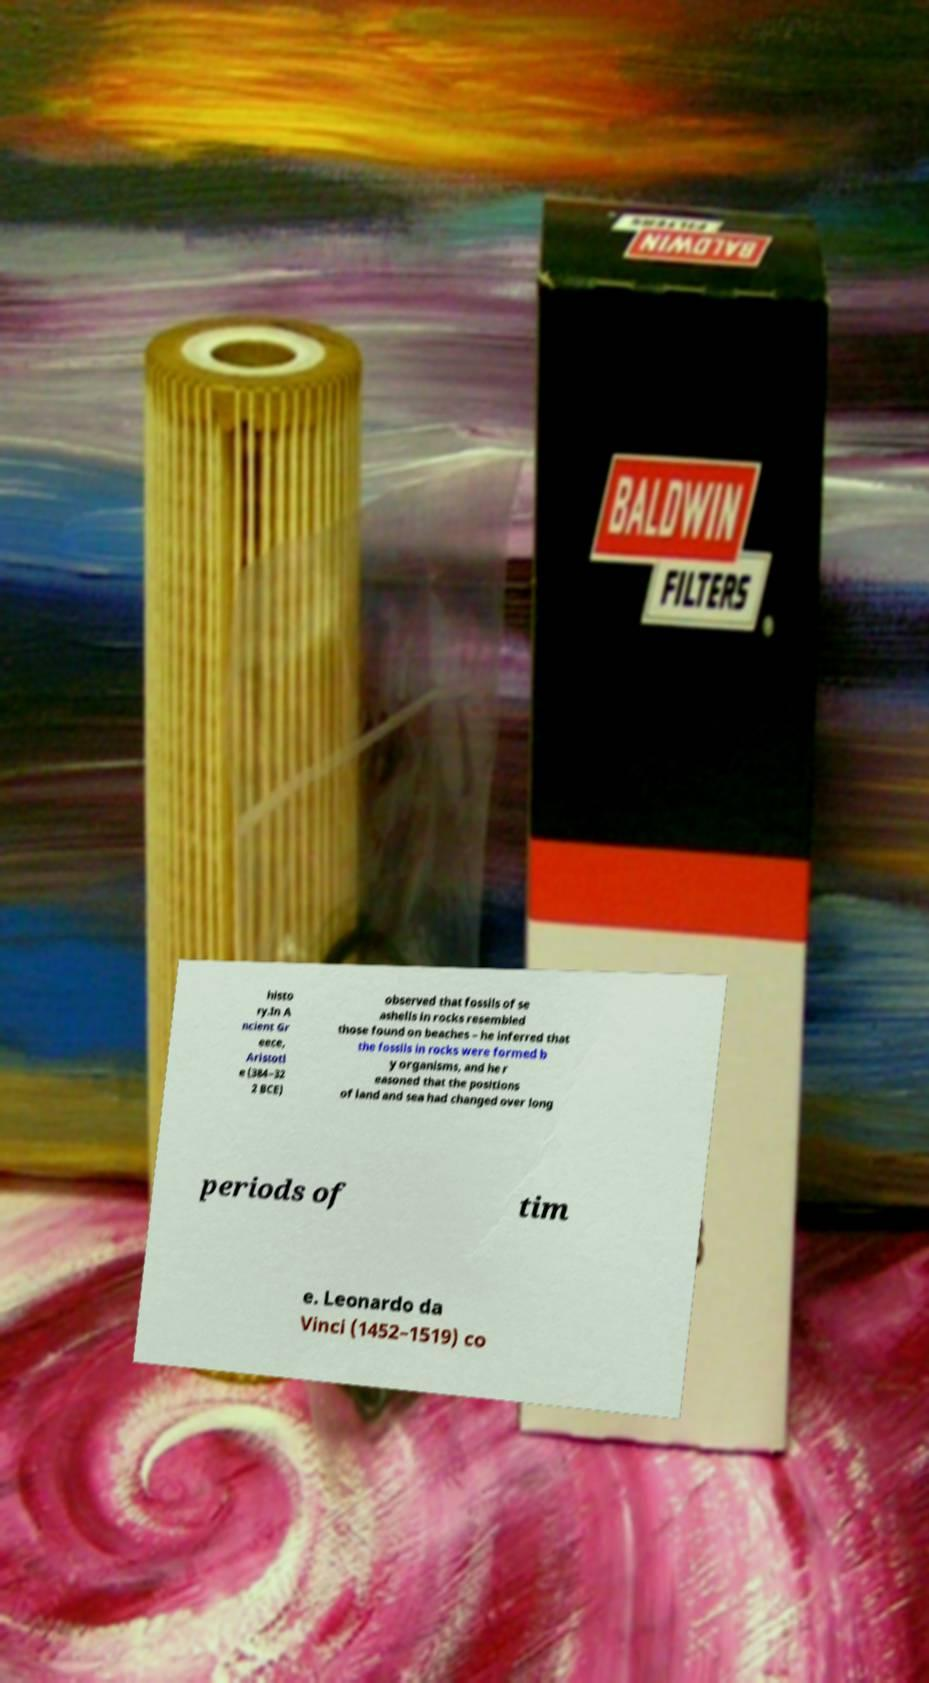Could you assist in decoding the text presented in this image and type it out clearly? histo ry.In A ncient Gr eece, Aristotl e (384–32 2 BCE) observed that fossils of se ashells in rocks resembled those found on beaches – he inferred that the fossils in rocks were formed b y organisms, and he r easoned that the positions of land and sea had changed over long periods of tim e. Leonardo da Vinci (1452–1519) co 